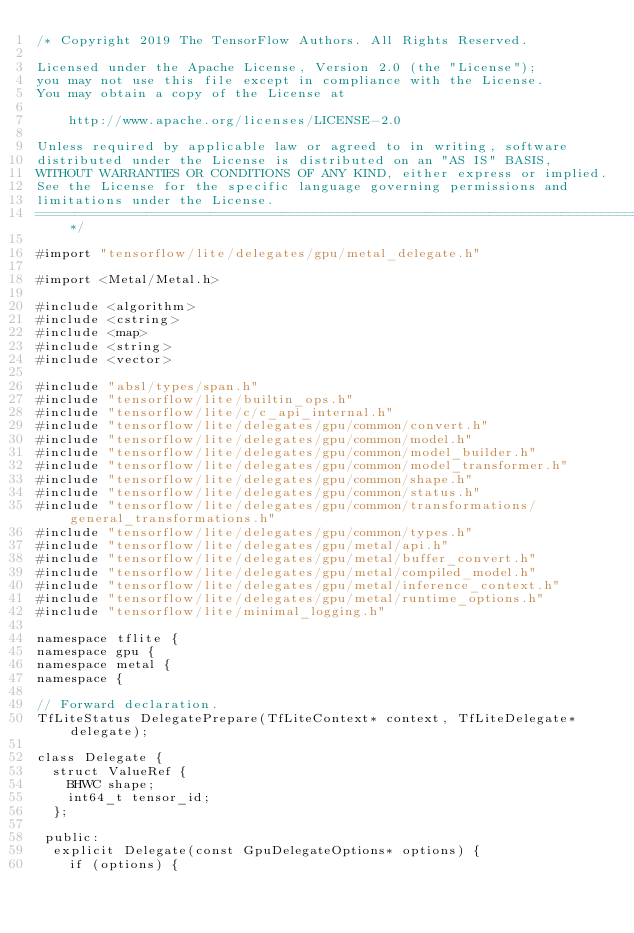Convert code to text. <code><loc_0><loc_0><loc_500><loc_500><_ObjectiveC_>/* Copyright 2019 The TensorFlow Authors. All Rights Reserved.

Licensed under the Apache License, Version 2.0 (the "License");
you may not use this file except in compliance with the License.
You may obtain a copy of the License at

    http://www.apache.org/licenses/LICENSE-2.0

Unless required by applicable law or agreed to in writing, software
distributed under the License is distributed on an "AS IS" BASIS,
WITHOUT WARRANTIES OR CONDITIONS OF ANY KIND, either express or implied.
See the License for the specific language governing permissions and
limitations under the License.
==============================================================================*/

#import "tensorflow/lite/delegates/gpu/metal_delegate.h"

#import <Metal/Metal.h>

#include <algorithm>
#include <cstring>
#include <map>
#include <string>
#include <vector>

#include "absl/types/span.h"
#include "tensorflow/lite/builtin_ops.h"
#include "tensorflow/lite/c/c_api_internal.h"
#include "tensorflow/lite/delegates/gpu/common/convert.h"
#include "tensorflow/lite/delegates/gpu/common/model.h"
#include "tensorflow/lite/delegates/gpu/common/model_builder.h"
#include "tensorflow/lite/delegates/gpu/common/model_transformer.h"
#include "tensorflow/lite/delegates/gpu/common/shape.h"
#include "tensorflow/lite/delegates/gpu/common/status.h"
#include "tensorflow/lite/delegates/gpu/common/transformations/general_transformations.h"
#include "tensorflow/lite/delegates/gpu/common/types.h"
#include "tensorflow/lite/delegates/gpu/metal/api.h"
#include "tensorflow/lite/delegates/gpu/metal/buffer_convert.h"
#include "tensorflow/lite/delegates/gpu/metal/compiled_model.h"
#include "tensorflow/lite/delegates/gpu/metal/inference_context.h"
#include "tensorflow/lite/delegates/gpu/metal/runtime_options.h"
#include "tensorflow/lite/minimal_logging.h"

namespace tflite {
namespace gpu {
namespace metal {
namespace {

// Forward declaration.
TfLiteStatus DelegatePrepare(TfLiteContext* context, TfLiteDelegate* delegate);

class Delegate {
  struct ValueRef {
    BHWC shape;
    int64_t tensor_id;
  };

 public:
  explicit Delegate(const GpuDelegateOptions* options) {
    if (options) {</code> 